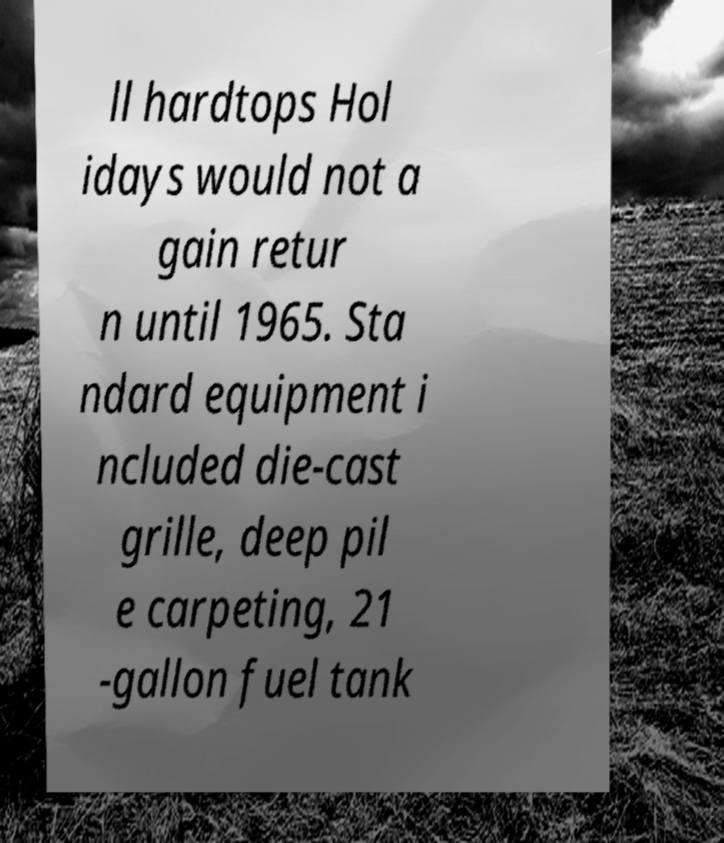For documentation purposes, I need the text within this image transcribed. Could you provide that? ll hardtops Hol idays would not a gain retur n until 1965. Sta ndard equipment i ncluded die-cast grille, deep pil e carpeting, 21 -gallon fuel tank 